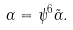<formula> <loc_0><loc_0><loc_500><loc_500>\alpha = \psi ^ { 6 } \tilde { \alpha } .</formula> 